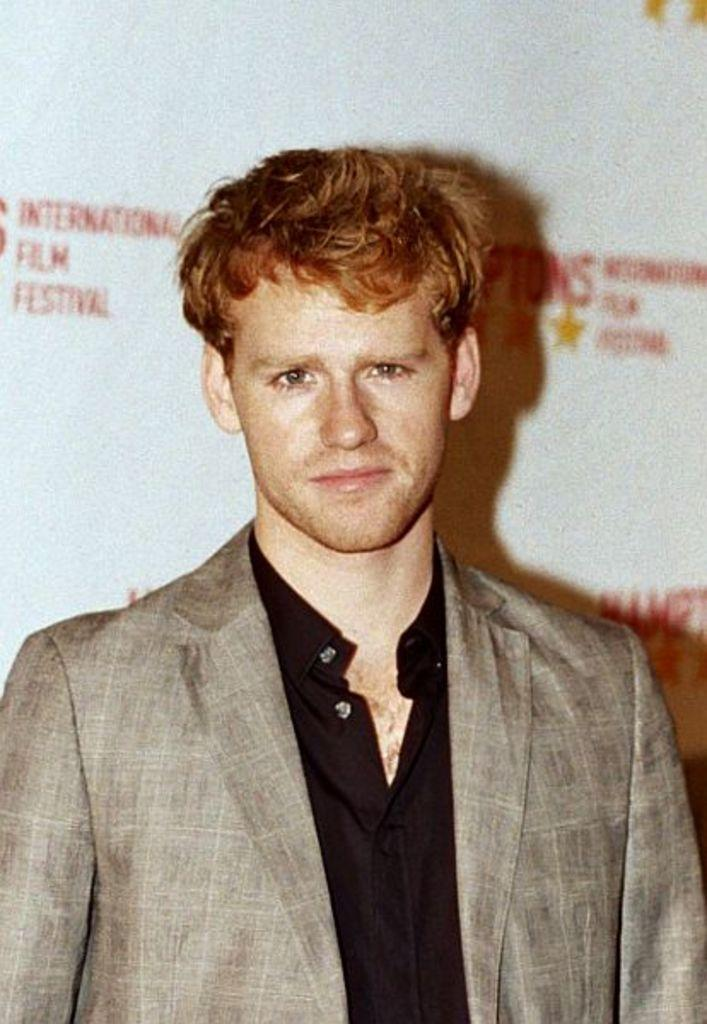What is the main subject of the picture? The main subject of the picture is a man. What is the man wearing in the picture? The man is wearing a brown coat and a black shirt. What is the man doing in the picture? The man is standing in front of the camera and giving a pose. What can be seen in the background of the picture? There is a white color banner in the background. What type of lawyer is the man in the picture? The image does not indicate that the man is a lawyer, nor is there any information about his profession. How many quarters can be seen in the picture? There are no quarters visible in the picture. 